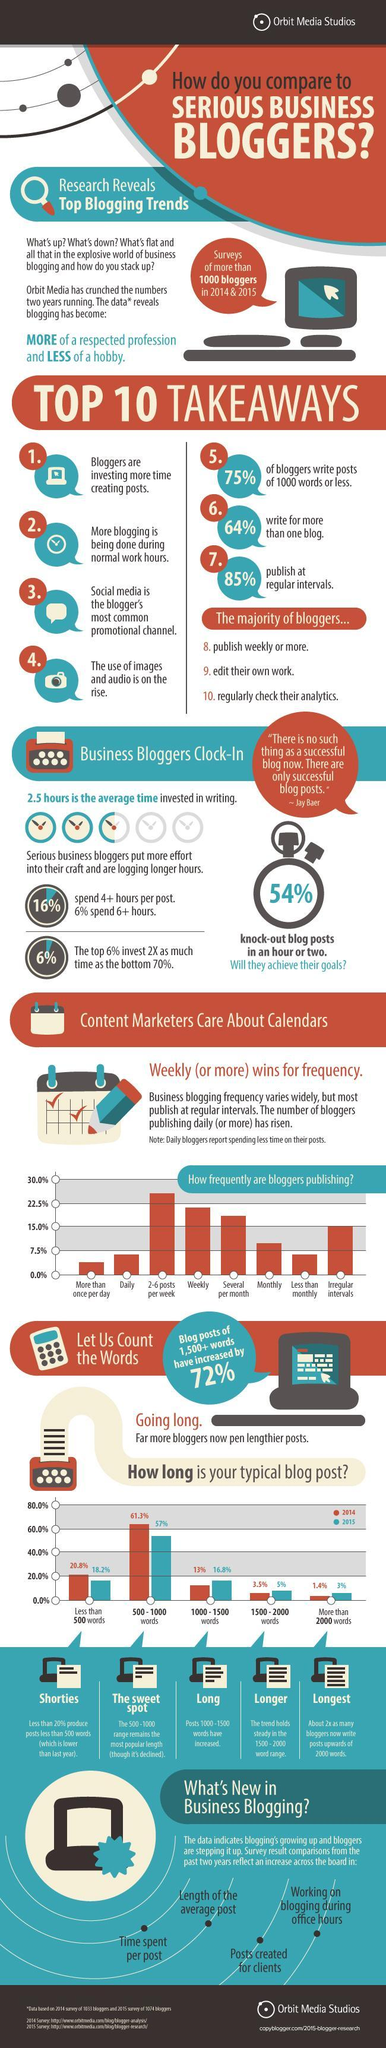In 2015, what percentage of blog posts had 500-1000 words?
Answer the question with a short phrase. 57% What percentage of people post at irregular intervals? 15.0% 